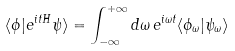<formula> <loc_0><loc_0><loc_500><loc_500>\langle \phi | e ^ { i t H } \psi \rangle = \int _ { - \infty } ^ { + \infty } d \omega \, e ^ { i \omega t } \langle \phi _ { \omega } | \psi _ { \omega } \rangle</formula> 